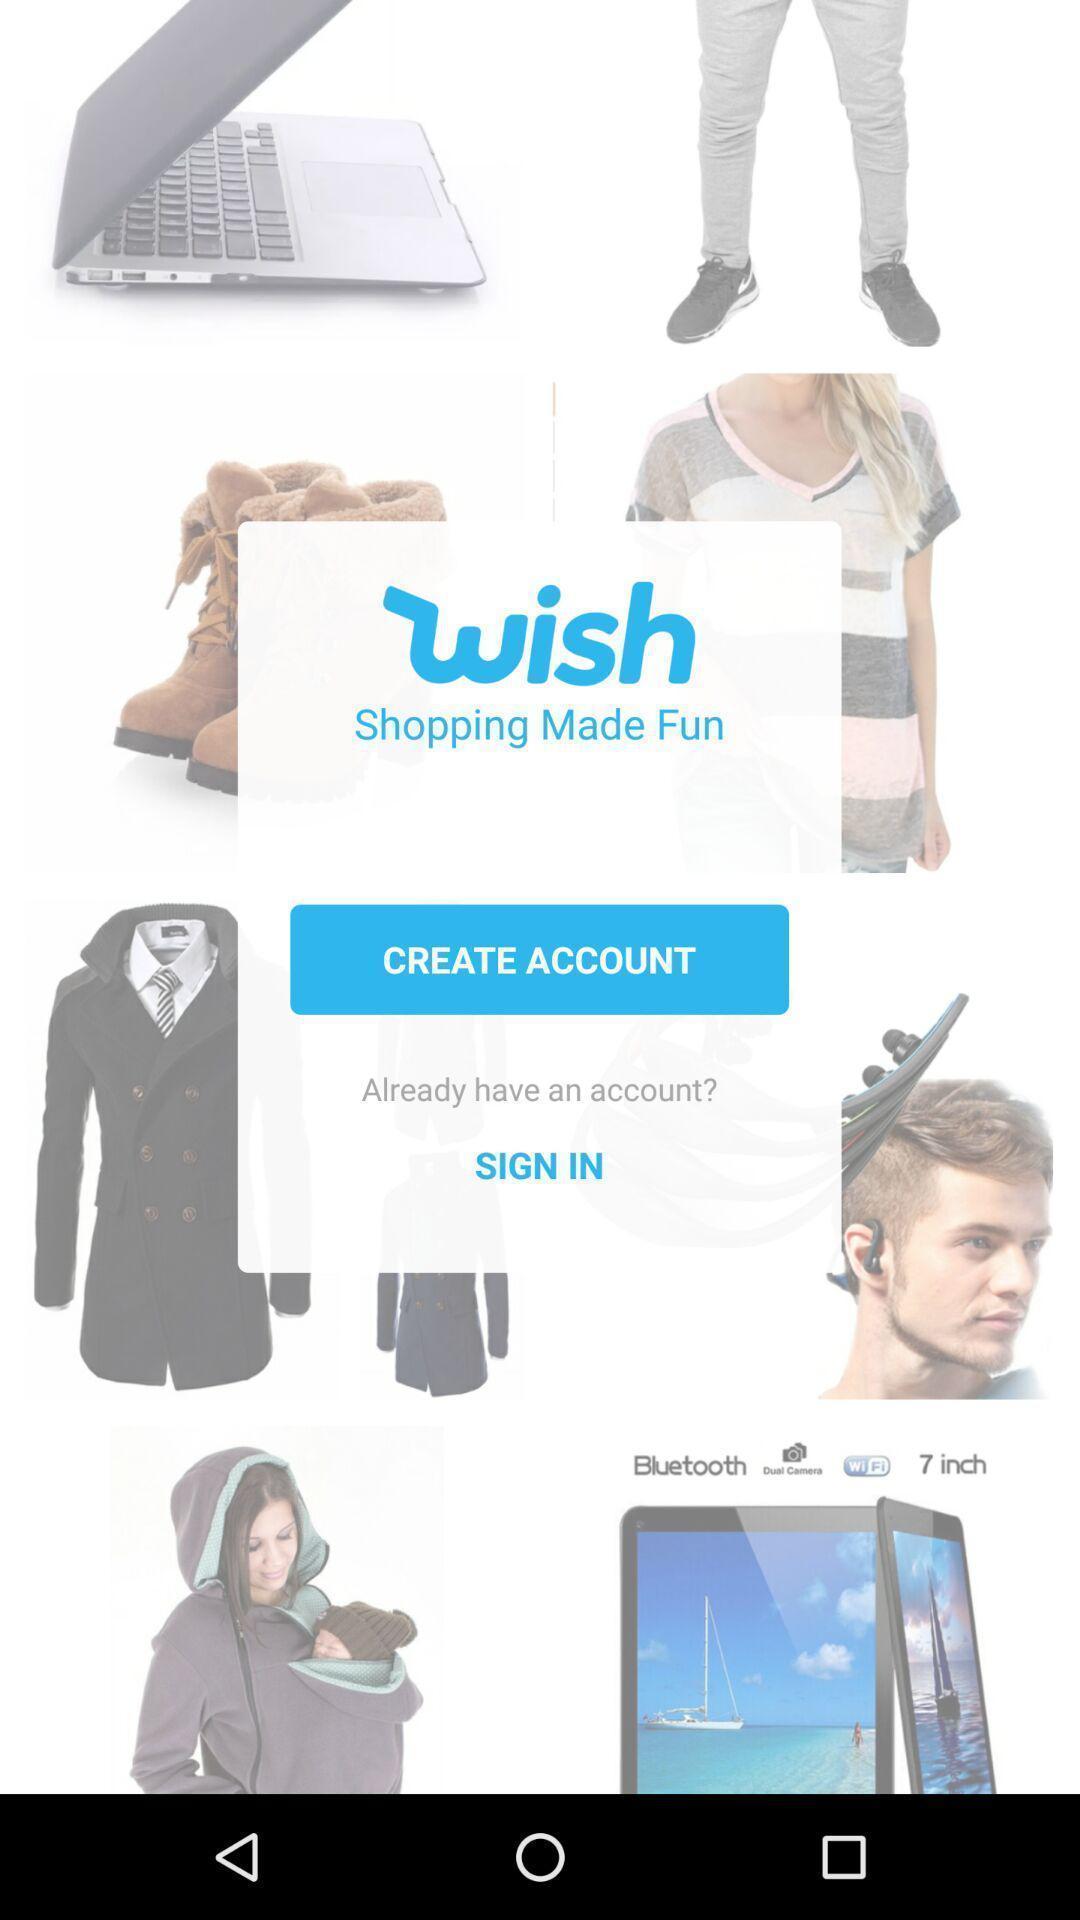What is the overall content of this screenshot? Sign in sign up page of a shopping application. 